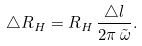Convert formula to latex. <formula><loc_0><loc_0><loc_500><loc_500>\triangle R _ { H } = R _ { H } \, \frac { \triangle l } { 2 \pi \, \tilde { \omega } } .</formula> 